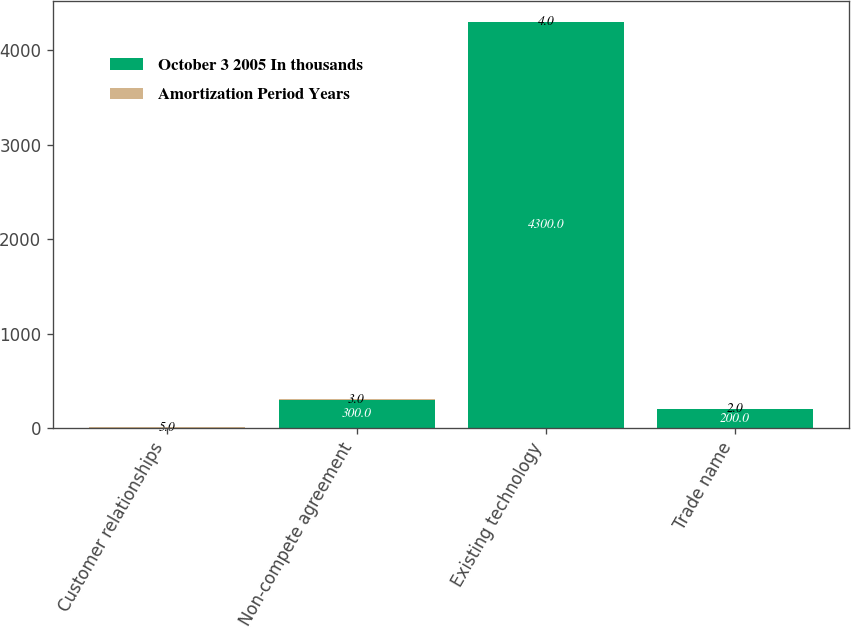Convert chart to OTSL. <chart><loc_0><loc_0><loc_500><loc_500><stacked_bar_chart><ecel><fcel>Customer relationships<fcel>Non-compete agreement<fcel>Existing technology<fcel>Trade name<nl><fcel>October 3 2005 In thousands<fcel>5<fcel>300<fcel>4300<fcel>200<nl><fcel>Amortization Period Years<fcel>5<fcel>3<fcel>4<fcel>2<nl></chart> 